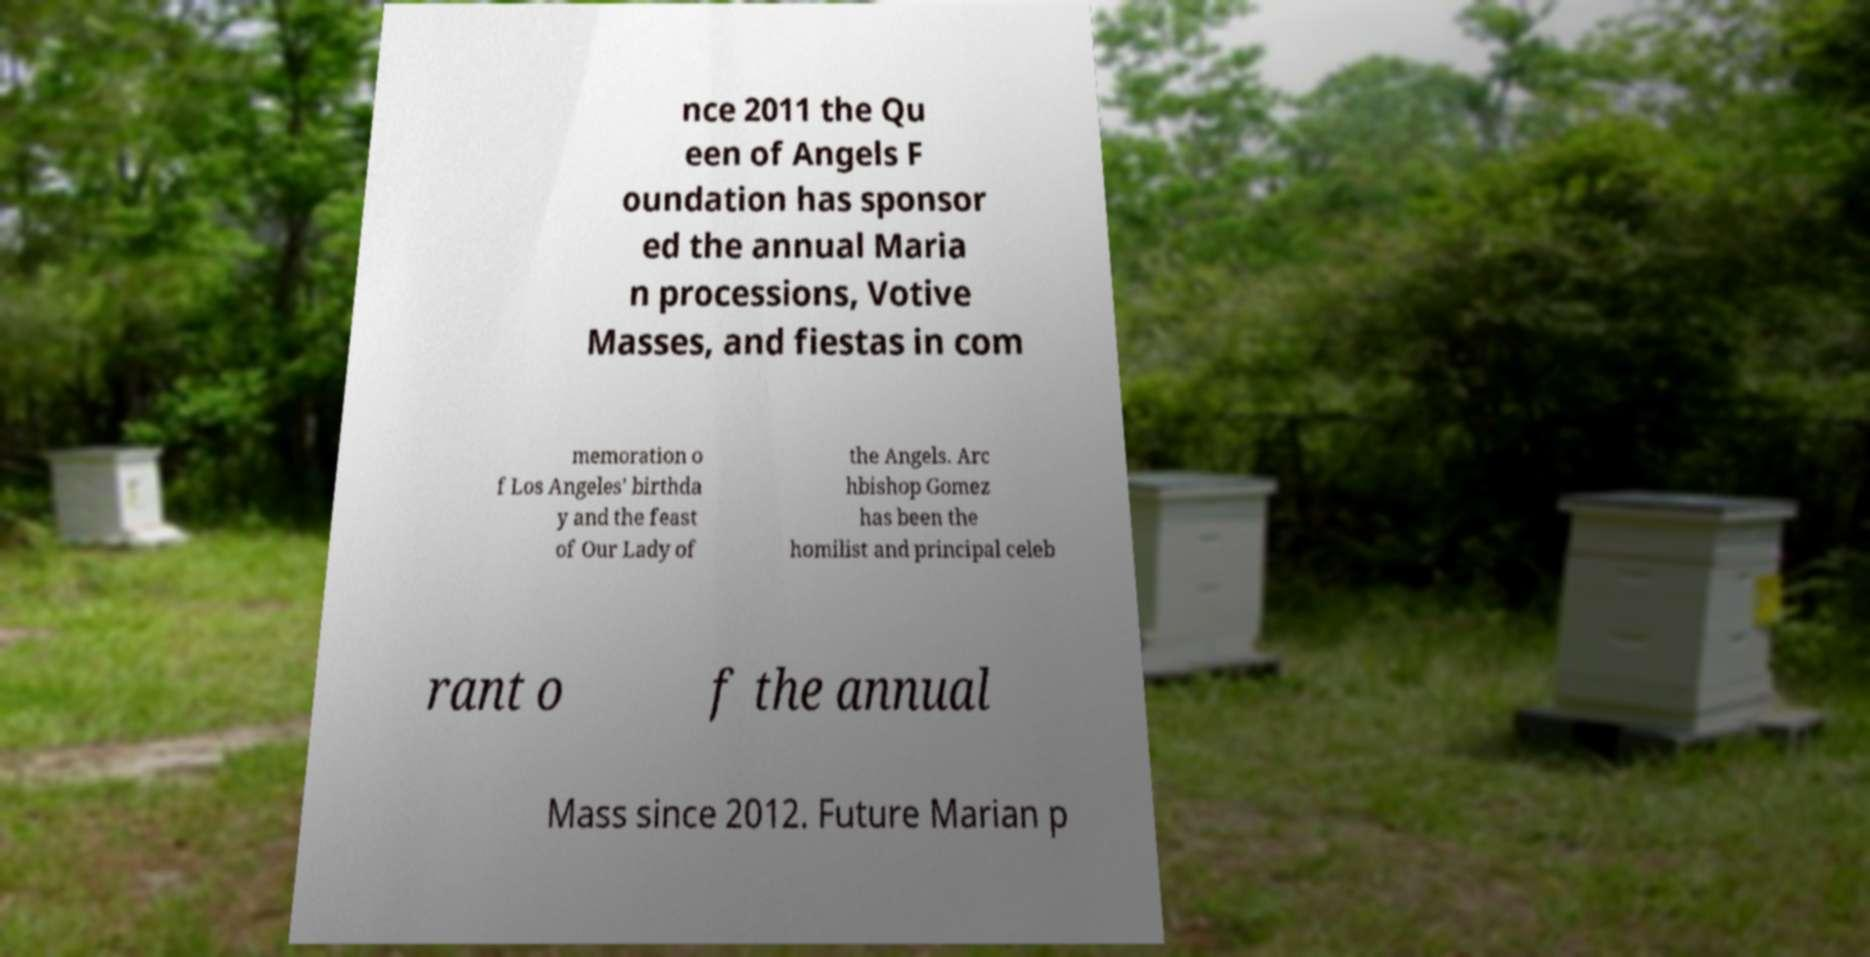I need the written content from this picture converted into text. Can you do that? nce 2011 the Qu een of Angels F oundation has sponsor ed the annual Maria n processions, Votive Masses, and fiestas in com memoration o f Los Angeles' birthda y and the feast of Our Lady of the Angels. Arc hbishop Gomez has been the homilist and principal celeb rant o f the annual Mass since 2012. Future Marian p 